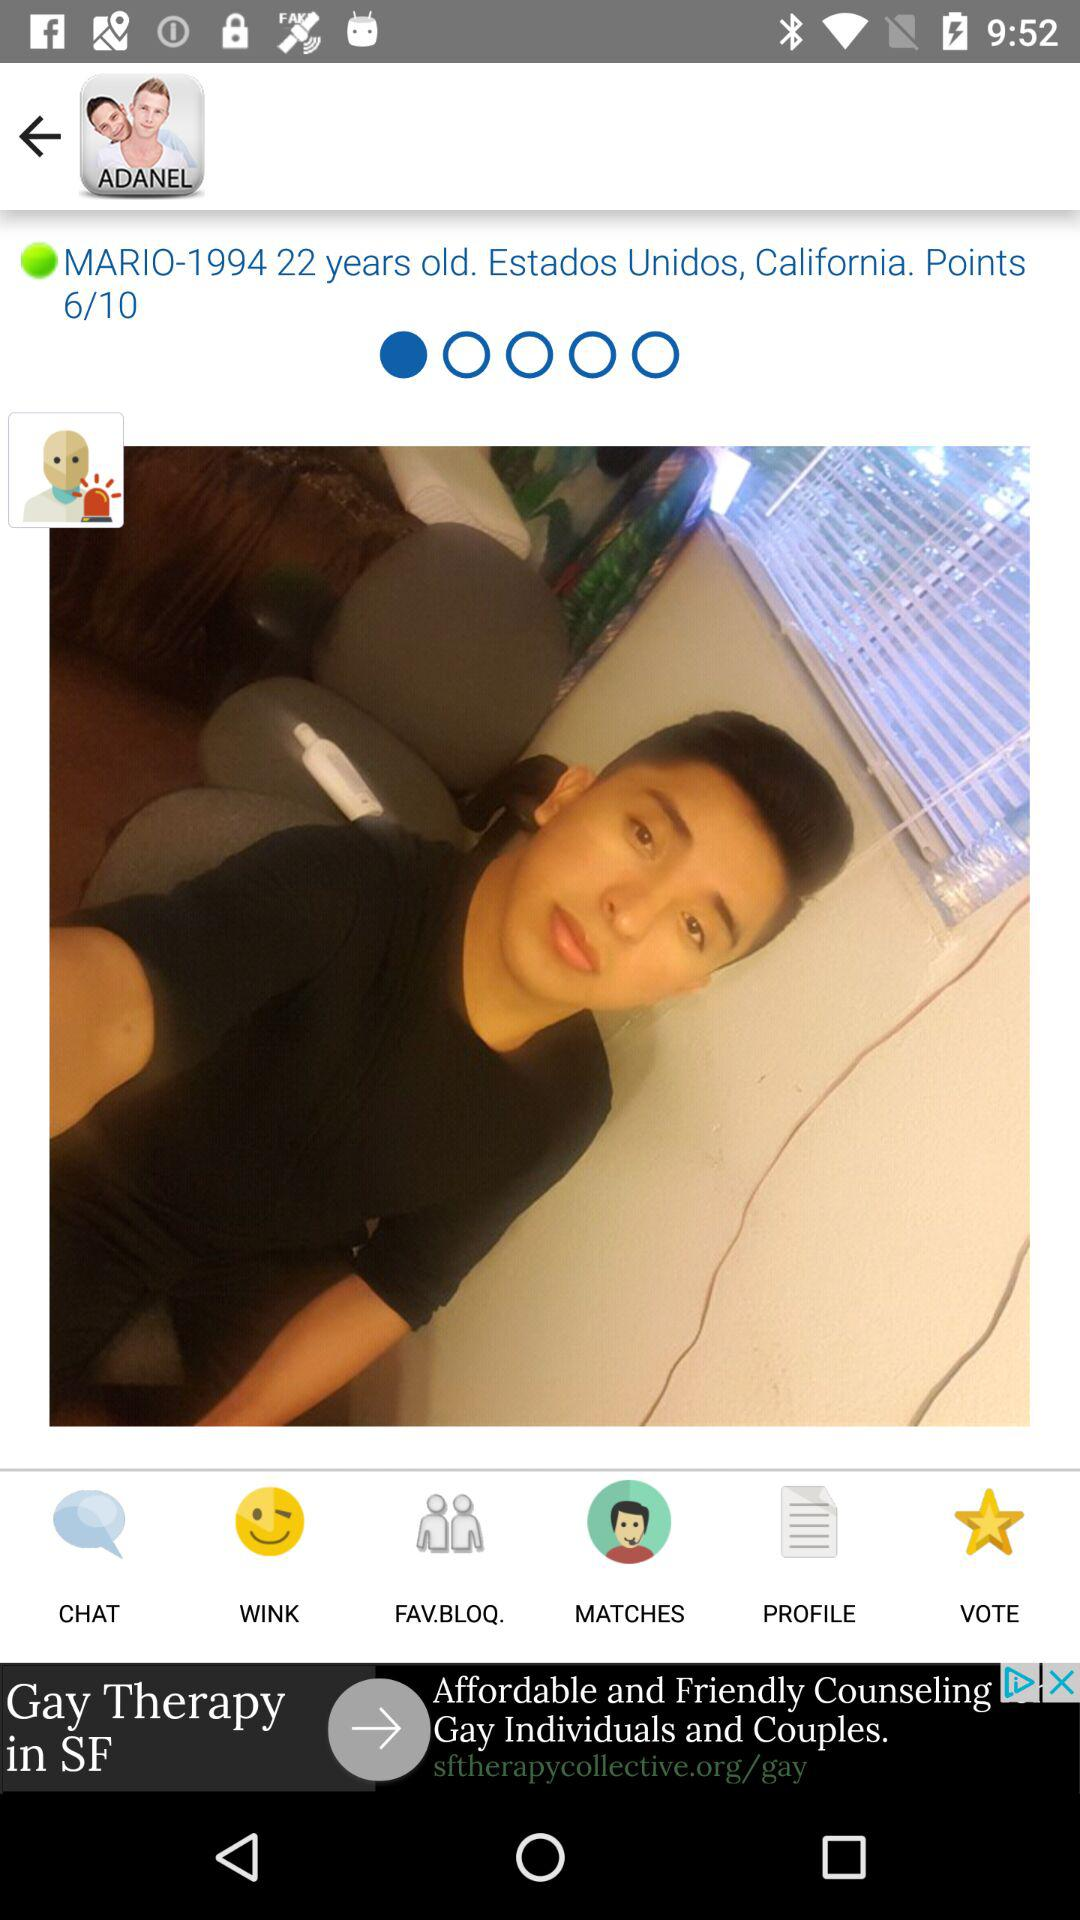What is the mentioned location? The mentioned location is Estados Unidos, California. 